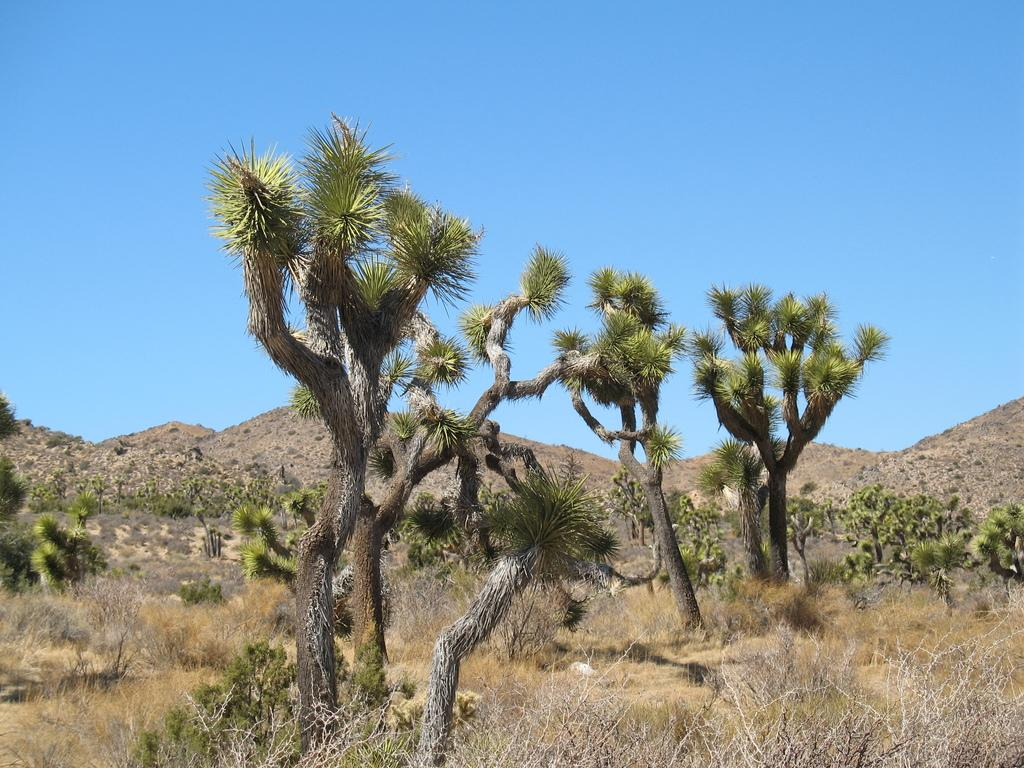What type of vegetation can be seen in the image? There is a group of trees and plants in the image. What can be seen in the distance behind the vegetation? Mountains are visible in the background of the image. What else is visible in the background of the image? The sky is visible in the background of the image. What type of glue is being used to hold the mountains together in the image? There is no glue present in the image, and the mountains are not being held together. 